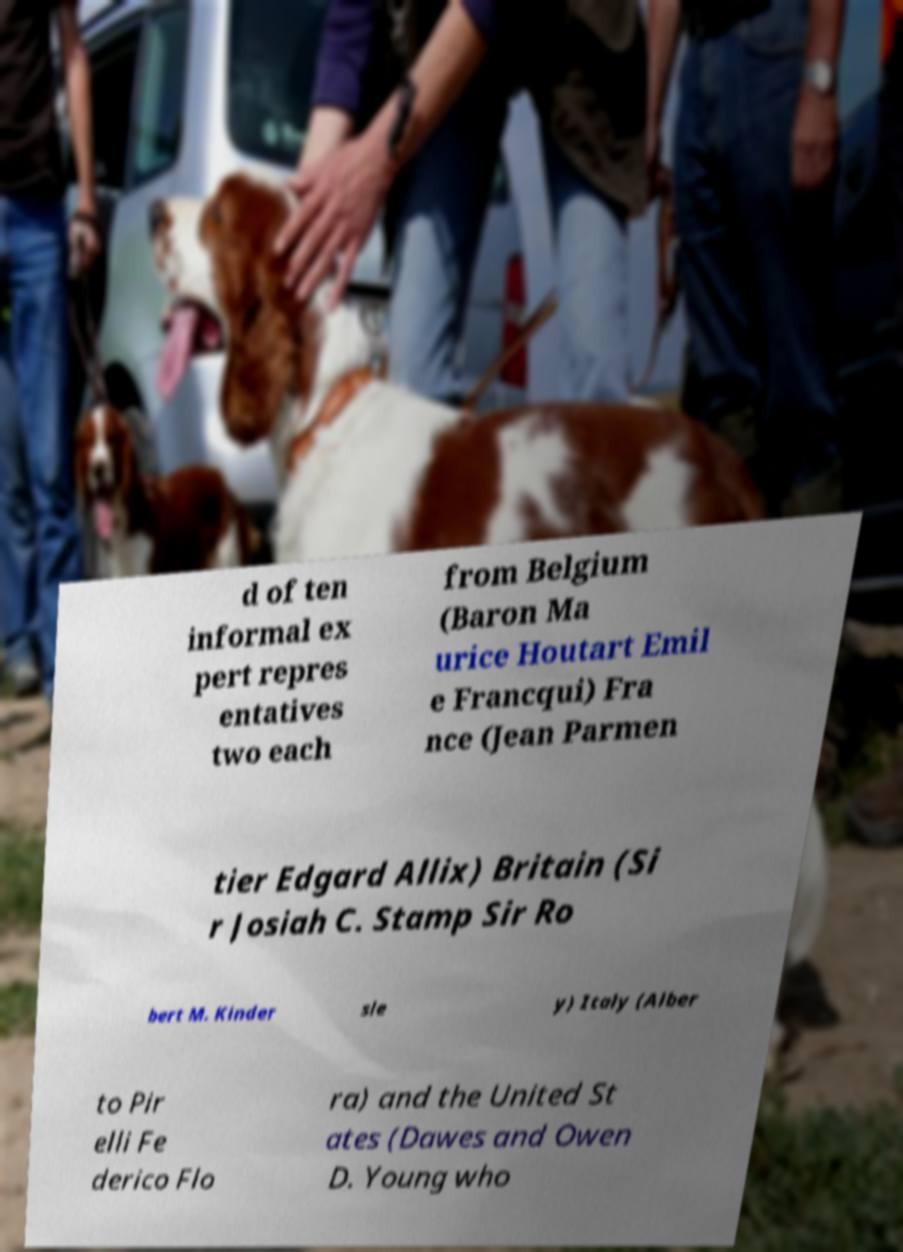There's text embedded in this image that I need extracted. Can you transcribe it verbatim? d of ten informal ex pert repres entatives two each from Belgium (Baron Ma urice Houtart Emil e Francqui) Fra nce (Jean Parmen tier Edgard Allix) Britain (Si r Josiah C. Stamp Sir Ro bert M. Kinder sle y) Italy (Alber to Pir elli Fe derico Flo ra) and the United St ates (Dawes and Owen D. Young who 